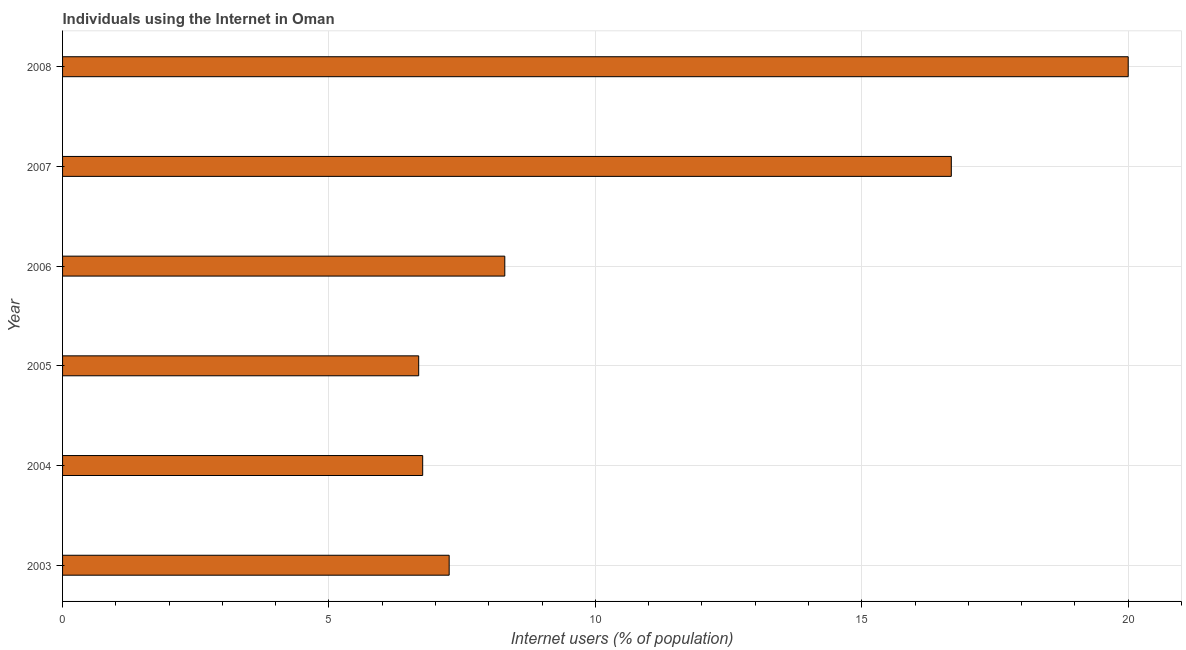What is the title of the graph?
Your answer should be very brief. Individuals using the Internet in Oman. What is the label or title of the X-axis?
Keep it short and to the point. Internet users (% of population). What is the number of internet users in 2007?
Offer a terse response. 16.68. Across all years, what is the maximum number of internet users?
Ensure brevity in your answer.  20. Across all years, what is the minimum number of internet users?
Your answer should be compact. 6.68. In which year was the number of internet users minimum?
Offer a very short reply. 2005. What is the sum of the number of internet users?
Make the answer very short. 65.68. What is the difference between the number of internet users in 2003 and 2008?
Offer a very short reply. -12.74. What is the average number of internet users per year?
Your answer should be compact. 10.95. What is the median number of internet users?
Give a very brief answer. 7.78. In how many years, is the number of internet users greater than 20 %?
Your answer should be very brief. 0. What is the ratio of the number of internet users in 2006 to that in 2008?
Your response must be concise. 0.41. Is the number of internet users in 2006 less than that in 2008?
Offer a very short reply. Yes. Is the difference between the number of internet users in 2007 and 2008 greater than the difference between any two years?
Give a very brief answer. No. What is the difference between the highest and the second highest number of internet users?
Give a very brief answer. 3.32. Is the sum of the number of internet users in 2006 and 2008 greater than the maximum number of internet users across all years?
Provide a short and direct response. Yes. What is the difference between the highest and the lowest number of internet users?
Give a very brief answer. 13.32. Are the values on the major ticks of X-axis written in scientific E-notation?
Your answer should be compact. No. What is the Internet users (% of population) of 2003?
Keep it short and to the point. 7.26. What is the Internet users (% of population) of 2004?
Your answer should be compact. 6.76. What is the Internet users (% of population) in 2005?
Ensure brevity in your answer.  6.68. What is the Internet users (% of population) in 2006?
Provide a short and direct response. 8.3. What is the Internet users (% of population) in 2007?
Your response must be concise. 16.68. What is the difference between the Internet users (% of population) in 2003 and 2004?
Give a very brief answer. 0.5. What is the difference between the Internet users (% of population) in 2003 and 2005?
Your answer should be very brief. 0.57. What is the difference between the Internet users (% of population) in 2003 and 2006?
Your response must be concise. -1.04. What is the difference between the Internet users (% of population) in 2003 and 2007?
Offer a very short reply. -9.42. What is the difference between the Internet users (% of population) in 2003 and 2008?
Keep it short and to the point. -12.74. What is the difference between the Internet users (% of population) in 2004 and 2005?
Make the answer very short. 0.08. What is the difference between the Internet users (% of population) in 2004 and 2006?
Ensure brevity in your answer.  -1.54. What is the difference between the Internet users (% of population) in 2004 and 2007?
Make the answer very short. -9.92. What is the difference between the Internet users (% of population) in 2004 and 2008?
Your response must be concise. -13.24. What is the difference between the Internet users (% of population) in 2005 and 2006?
Ensure brevity in your answer.  -1.62. What is the difference between the Internet users (% of population) in 2005 and 2007?
Your response must be concise. -10. What is the difference between the Internet users (% of population) in 2005 and 2008?
Your answer should be compact. -13.32. What is the difference between the Internet users (% of population) in 2006 and 2007?
Offer a terse response. -8.38. What is the difference between the Internet users (% of population) in 2006 and 2008?
Your answer should be compact. -11.7. What is the difference between the Internet users (% of population) in 2007 and 2008?
Give a very brief answer. -3.32. What is the ratio of the Internet users (% of population) in 2003 to that in 2004?
Offer a very short reply. 1.07. What is the ratio of the Internet users (% of population) in 2003 to that in 2005?
Offer a terse response. 1.09. What is the ratio of the Internet users (% of population) in 2003 to that in 2006?
Give a very brief answer. 0.87. What is the ratio of the Internet users (% of population) in 2003 to that in 2007?
Provide a short and direct response. 0.43. What is the ratio of the Internet users (% of population) in 2003 to that in 2008?
Keep it short and to the point. 0.36. What is the ratio of the Internet users (% of population) in 2004 to that in 2006?
Offer a terse response. 0.81. What is the ratio of the Internet users (% of population) in 2004 to that in 2007?
Give a very brief answer. 0.41. What is the ratio of the Internet users (% of population) in 2004 to that in 2008?
Your answer should be compact. 0.34. What is the ratio of the Internet users (% of population) in 2005 to that in 2006?
Your answer should be compact. 0.81. What is the ratio of the Internet users (% of population) in 2005 to that in 2007?
Your response must be concise. 0.4. What is the ratio of the Internet users (% of population) in 2005 to that in 2008?
Offer a terse response. 0.33. What is the ratio of the Internet users (% of population) in 2006 to that in 2007?
Provide a short and direct response. 0.5. What is the ratio of the Internet users (% of population) in 2006 to that in 2008?
Ensure brevity in your answer.  0.41. What is the ratio of the Internet users (% of population) in 2007 to that in 2008?
Ensure brevity in your answer.  0.83. 